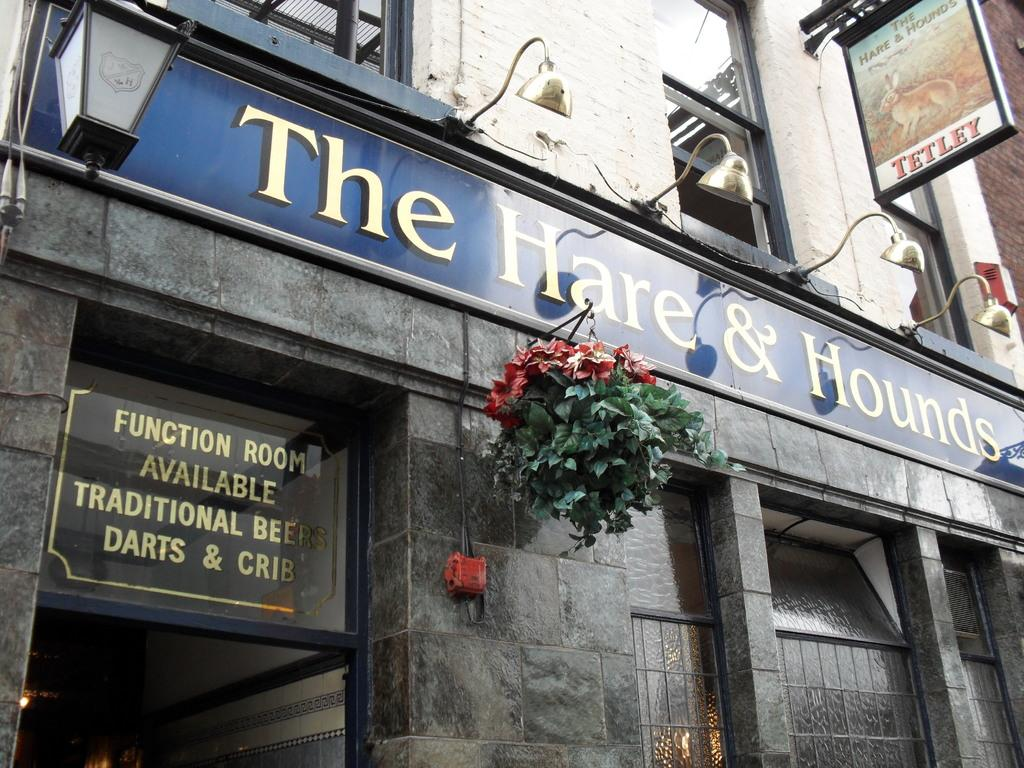<image>
Write a terse but informative summary of the picture. A sign notes the availability of rooms at the Hare and Hounds pub viewed from outside. 